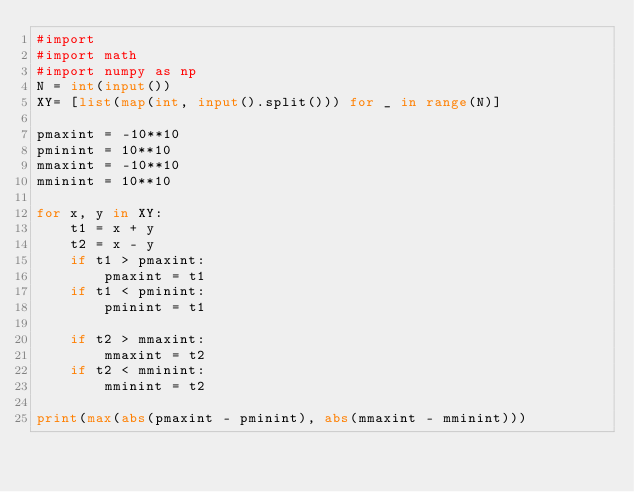<code> <loc_0><loc_0><loc_500><loc_500><_Python_>#import
#import math
#import numpy as np
N = int(input())
XY= [list(map(int, input().split())) for _ in range(N)]

pmaxint = -10**10
pminint = 10**10
mmaxint = -10**10
mminint = 10**10

for x, y in XY:
    t1 = x + y
    t2 = x - y
    if t1 > pmaxint:
        pmaxint = t1
    if t1 < pminint:
        pminint = t1
    
    if t2 > mmaxint:
        mmaxint = t2
    if t2 < mminint:
        mminint = t2

print(max(abs(pmaxint - pminint), abs(mmaxint - mminint)))</code> 